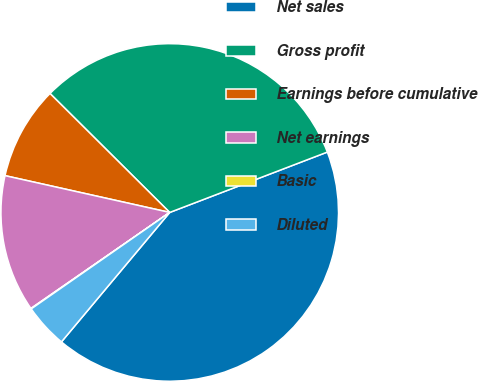Convert chart. <chart><loc_0><loc_0><loc_500><loc_500><pie_chart><fcel>Net sales<fcel>Gross profit<fcel>Earnings before cumulative<fcel>Net earnings<fcel>Basic<fcel>Diluted<nl><fcel>41.91%<fcel>31.73%<fcel>8.95%<fcel>13.13%<fcel>0.05%<fcel>4.23%<nl></chart> 